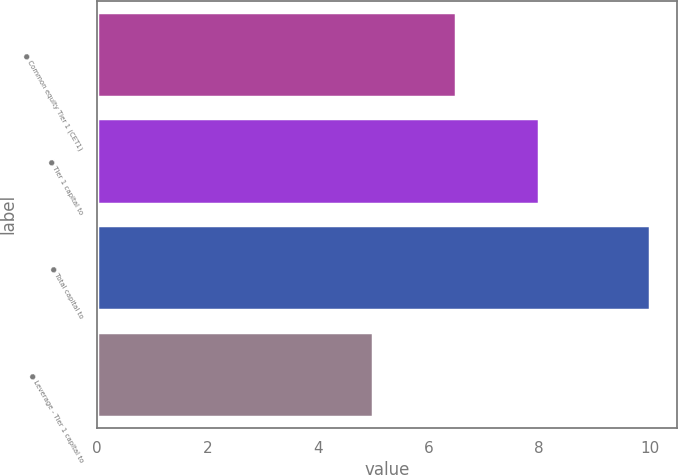Convert chart to OTSL. <chart><loc_0><loc_0><loc_500><loc_500><bar_chart><fcel>● Common equity Tier 1 (CET1)<fcel>● Tier 1 capital to<fcel>● Total capital to<fcel>● Leverage - Tier 1 capital to<nl><fcel>6.5<fcel>8<fcel>10<fcel>5<nl></chart> 